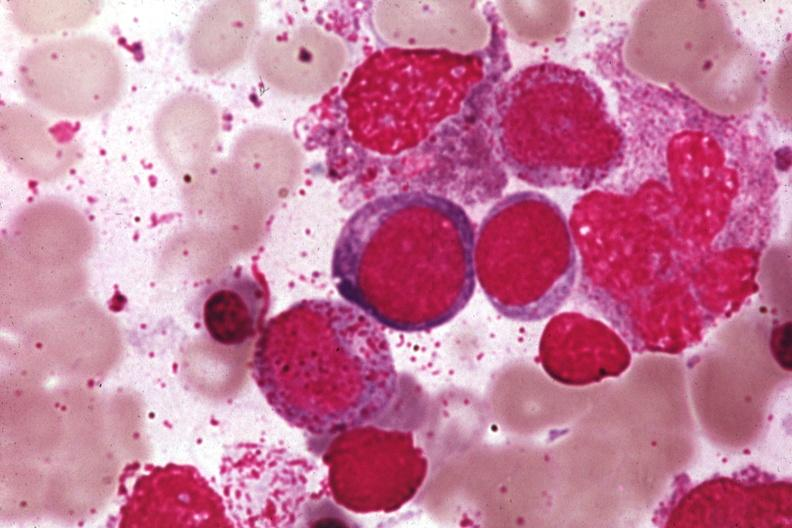s six digits present?
Answer the question using a single word or phrase. No 